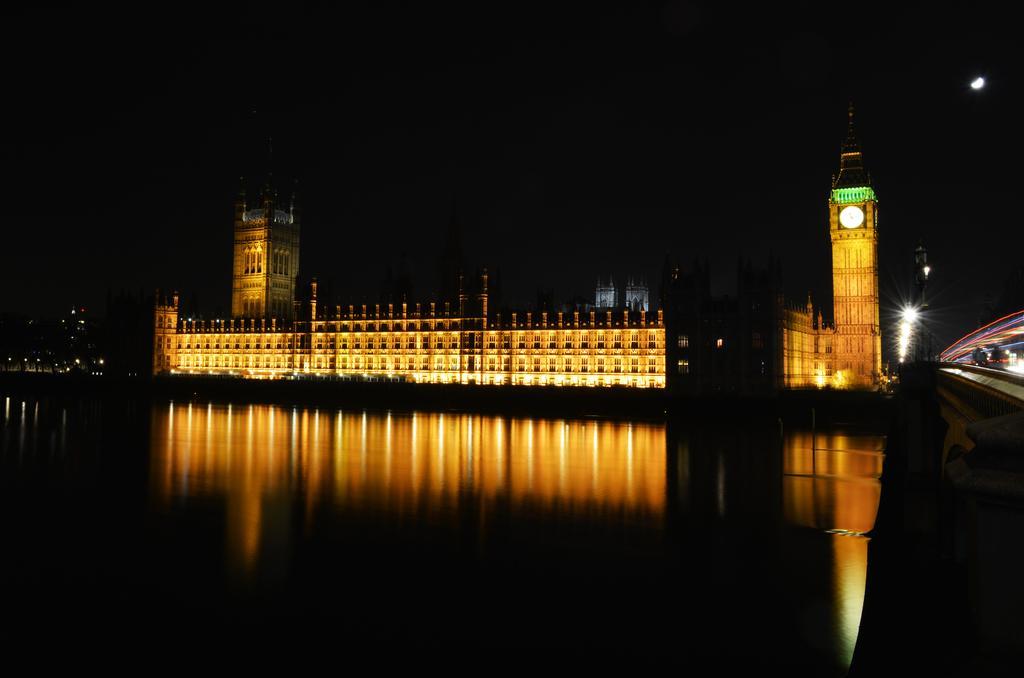Could you give a brief overview of what you see in this image? In this picture we can observe river. There is a building. We can observe yellow color light on the building. On the right side there is a clock tower. The background is completely dark. 